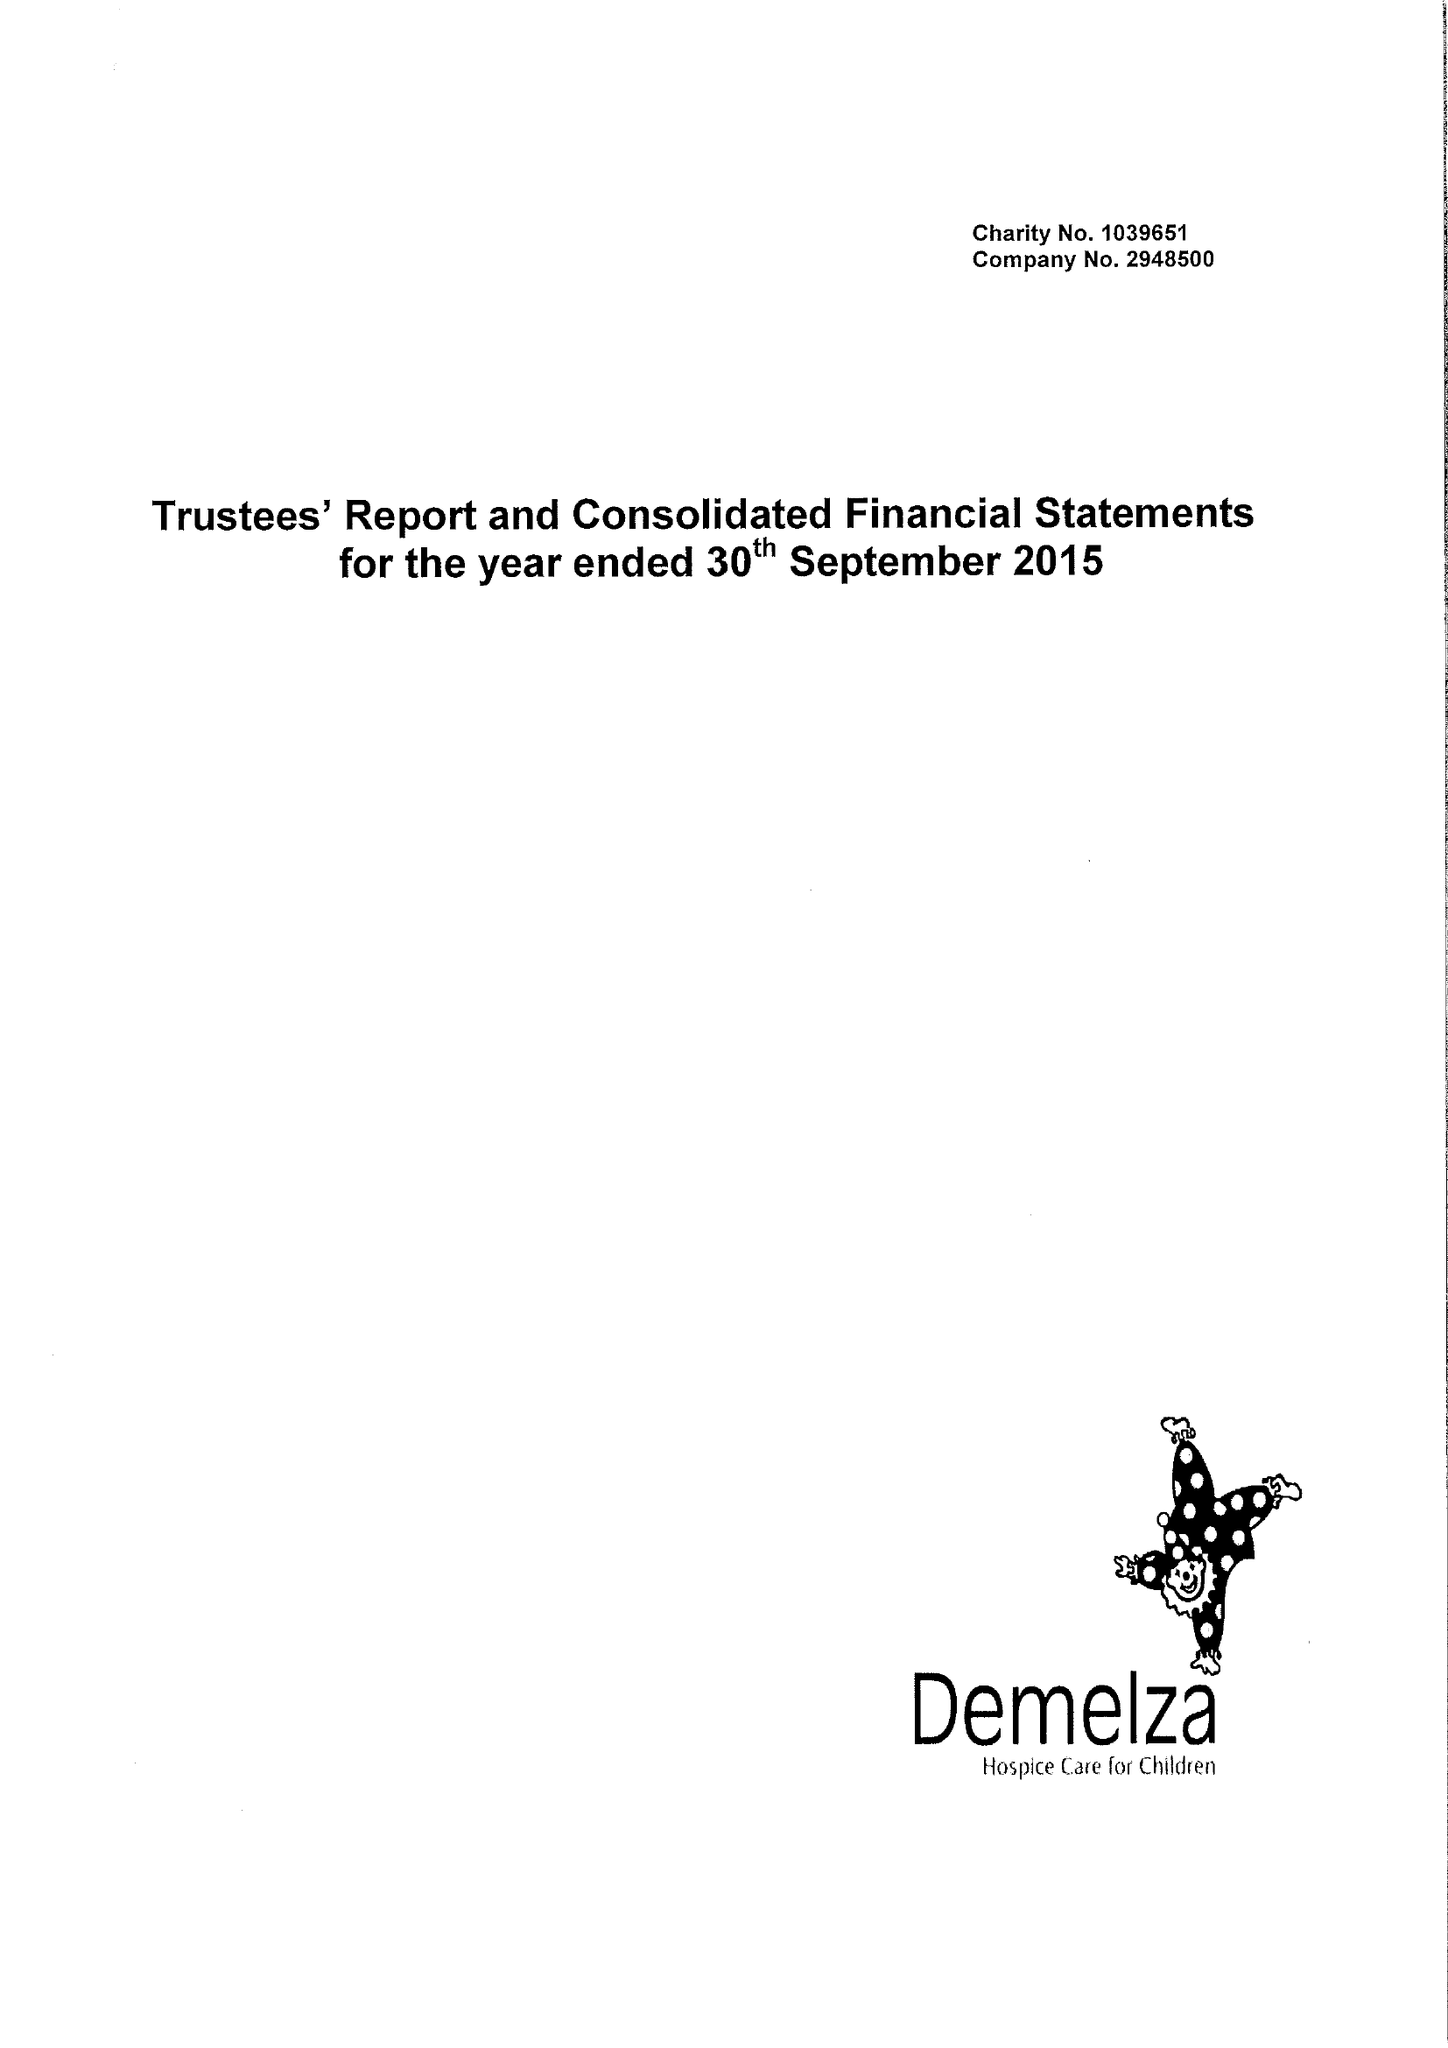What is the value for the spending_annually_in_british_pounds?
Answer the question using a single word or phrase. 10541899.00 